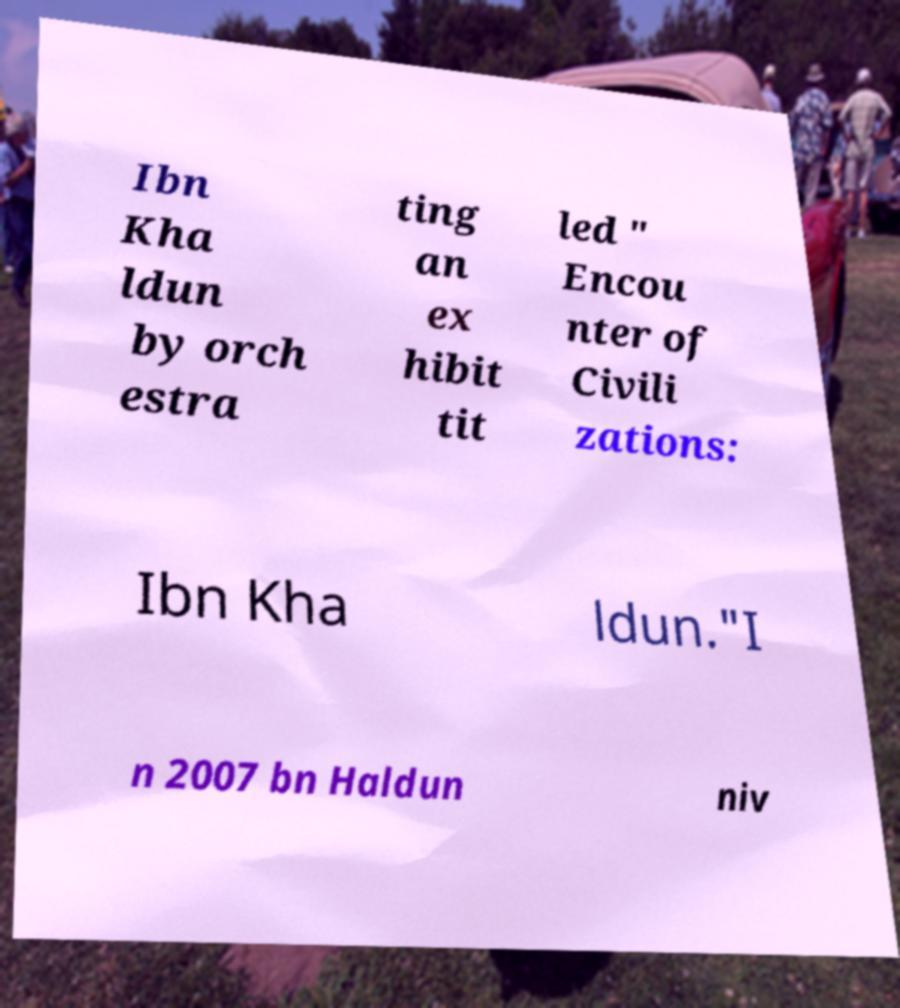I need the written content from this picture converted into text. Can you do that? Ibn Kha ldun by orch estra ting an ex hibit tit led " Encou nter of Civili zations: Ibn Kha ldun."I n 2007 bn Haldun niv 